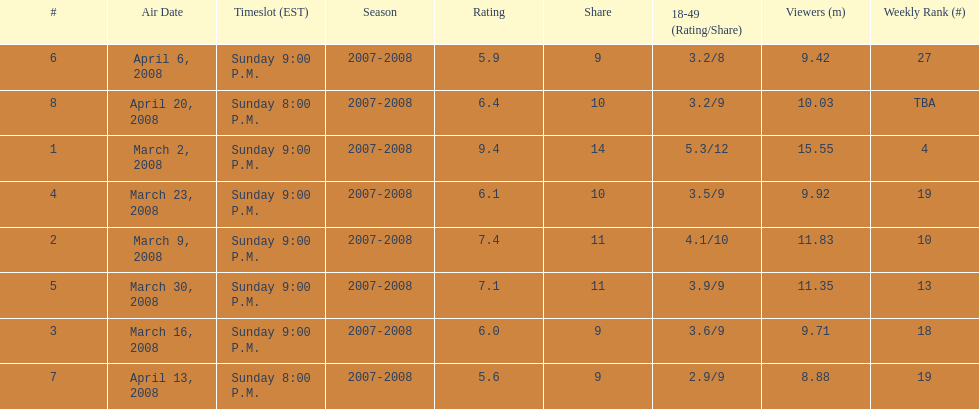What episode had the highest rating? March 2, 2008. Give me the full table as a dictionary. {'header': ['#', 'Air Date', 'Timeslot (EST)', 'Season', 'Rating', 'Share', '18-49 (Rating/Share)', 'Viewers (m)', 'Weekly Rank (#)'], 'rows': [['6', 'April 6, 2008', 'Sunday 9:00 P.M.', '2007-2008', '5.9', '9', '3.2/8', '9.42', '27'], ['8', 'April 20, 2008', 'Sunday 8:00 P.M.', '2007-2008', '6.4', '10', '3.2/9', '10.03', 'TBA'], ['1', 'March 2, 2008', 'Sunday 9:00 P.M.', '2007-2008', '9.4', '14', '5.3/12', '15.55', '4'], ['4', 'March 23, 2008', 'Sunday 9:00 P.M.', '2007-2008', '6.1', '10', '3.5/9', '9.92', '19'], ['2', 'March 9, 2008', 'Sunday 9:00 P.M.', '2007-2008', '7.4', '11', '4.1/10', '11.83', '10'], ['5', 'March 30, 2008', 'Sunday 9:00 P.M.', '2007-2008', '7.1', '11', '3.9/9', '11.35', '13'], ['3', 'March 16, 2008', 'Sunday 9:00 P.M.', '2007-2008', '6.0', '9', '3.6/9', '9.71', '18'], ['7', 'April 13, 2008', 'Sunday 8:00 P.M.', '2007-2008', '5.6', '9', '2.9/9', '8.88', '19']]} 